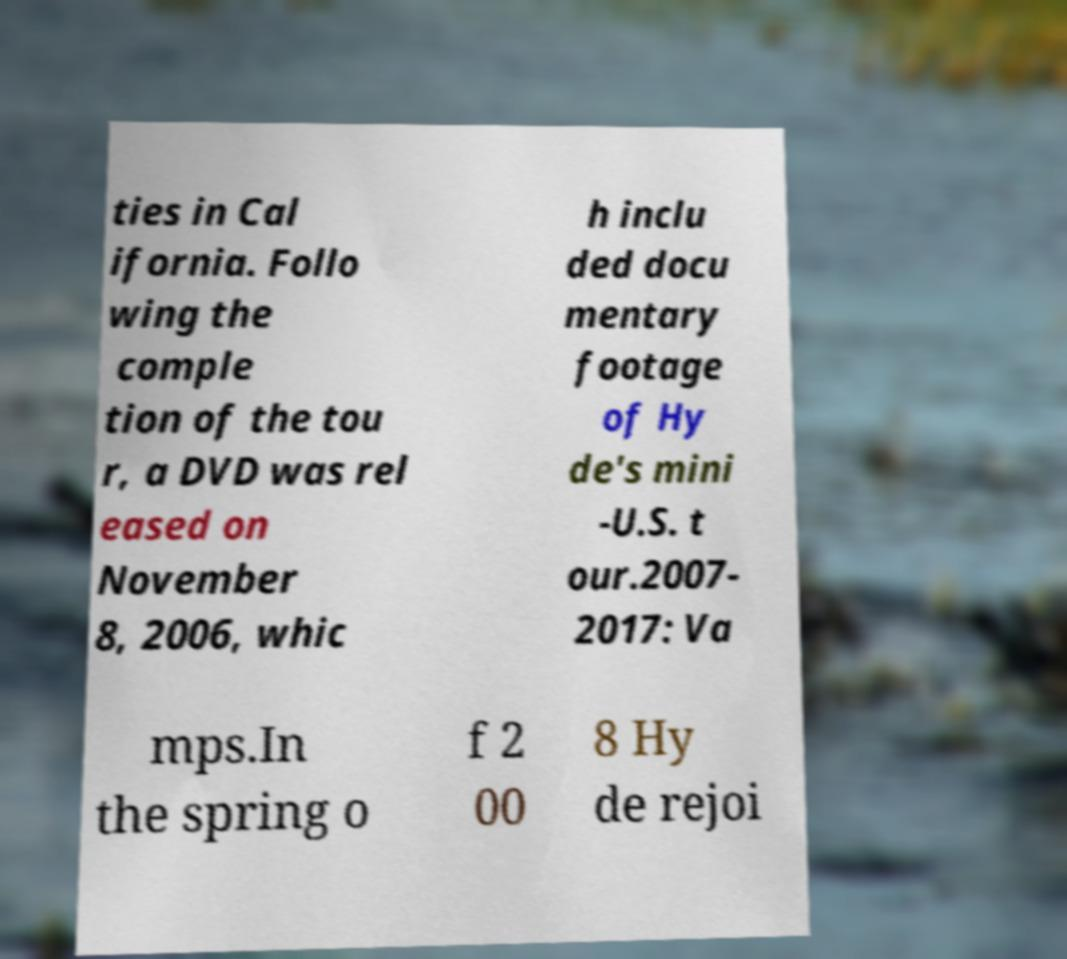For documentation purposes, I need the text within this image transcribed. Could you provide that? ties in Cal ifornia. Follo wing the comple tion of the tou r, a DVD was rel eased on November 8, 2006, whic h inclu ded docu mentary footage of Hy de's mini -U.S. t our.2007- 2017: Va mps.In the spring o f 2 00 8 Hy de rejoi 